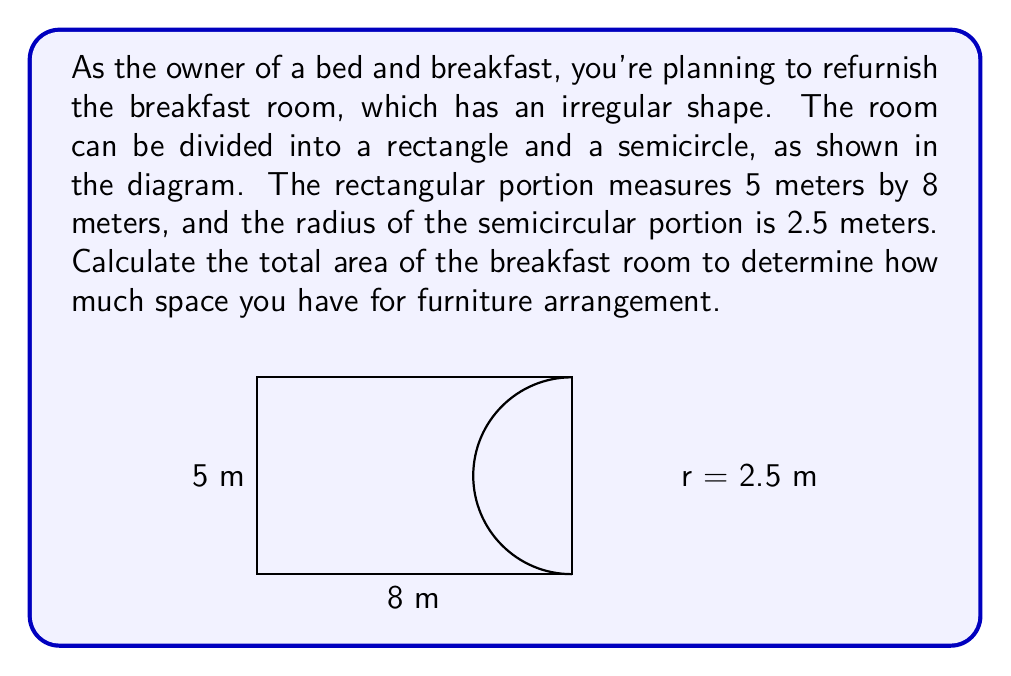Give your solution to this math problem. To calculate the total area of the irregularly shaped breakfast room, we need to:

1. Calculate the area of the rectangular portion:
   $A_{rectangle} = length \times width$
   $A_{rectangle} = 8 \text{ m} \times 5 \text{ m} = 40 \text{ m}^2$

2. Calculate the area of the semicircular portion:
   The area of a full circle is $A_{circle} = \pi r^2$
   For a semicircle, we use half of this formula:
   $A_{semicircle} = \frac{1}{2} \pi r^2$
   $A_{semicircle} = \frac{1}{2} \times \pi \times (2.5 \text{ m})^2$
   $A_{semicircle} = \frac{1}{2} \times \pi \times 6.25 \text{ m}^2$
   $A_{semicircle} \approx 9.82 \text{ m}^2$

3. Sum the areas of both portions:
   $A_{total} = A_{rectangle} + A_{semicircle}$
   $A_{total} = 40 \text{ m}^2 + 9.82 \text{ m}^2$
   $A_{total} \approx 49.82 \text{ m}^2$

Therefore, the total area of the breakfast room is approximately 49.82 square meters.
Answer: $49.82 \text{ m}^2$ 